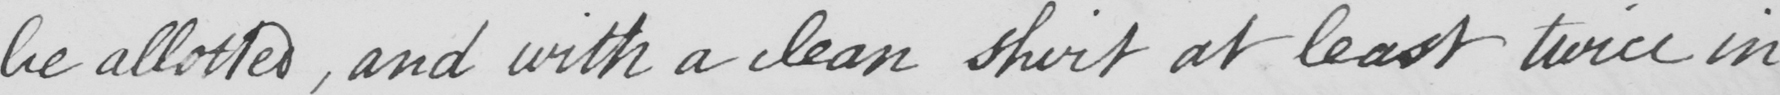What does this handwritten line say? be allotted, and with a clean shirt at least twice in 